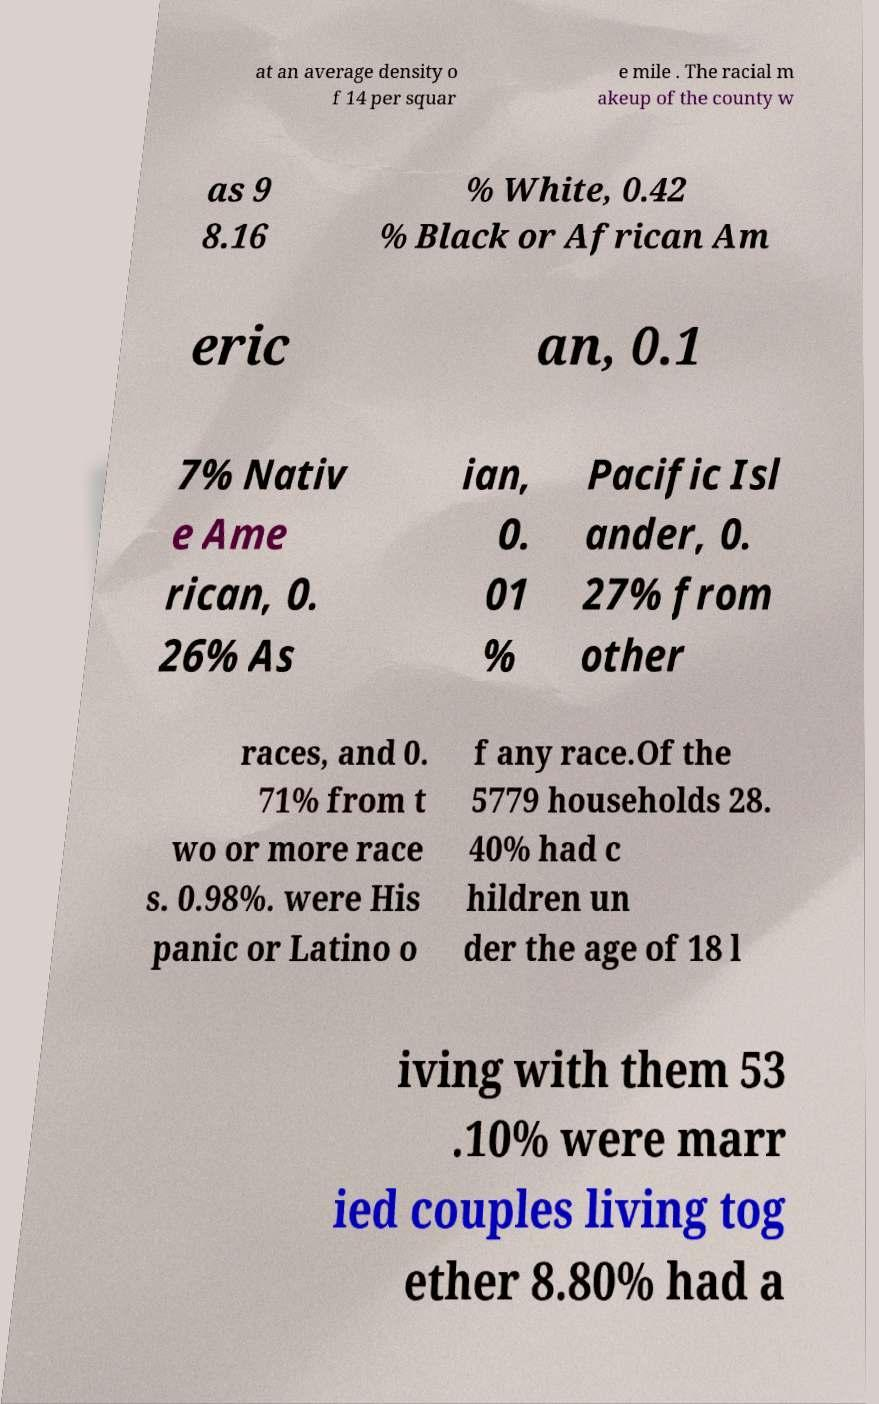Could you assist in decoding the text presented in this image and type it out clearly? at an average density o f 14 per squar e mile . The racial m akeup of the county w as 9 8.16 % White, 0.42 % Black or African Am eric an, 0.1 7% Nativ e Ame rican, 0. 26% As ian, 0. 01 % Pacific Isl ander, 0. 27% from other races, and 0. 71% from t wo or more race s. 0.98%. were His panic or Latino o f any race.Of the 5779 households 28. 40% had c hildren un der the age of 18 l iving with them 53 .10% were marr ied couples living tog ether 8.80% had a 